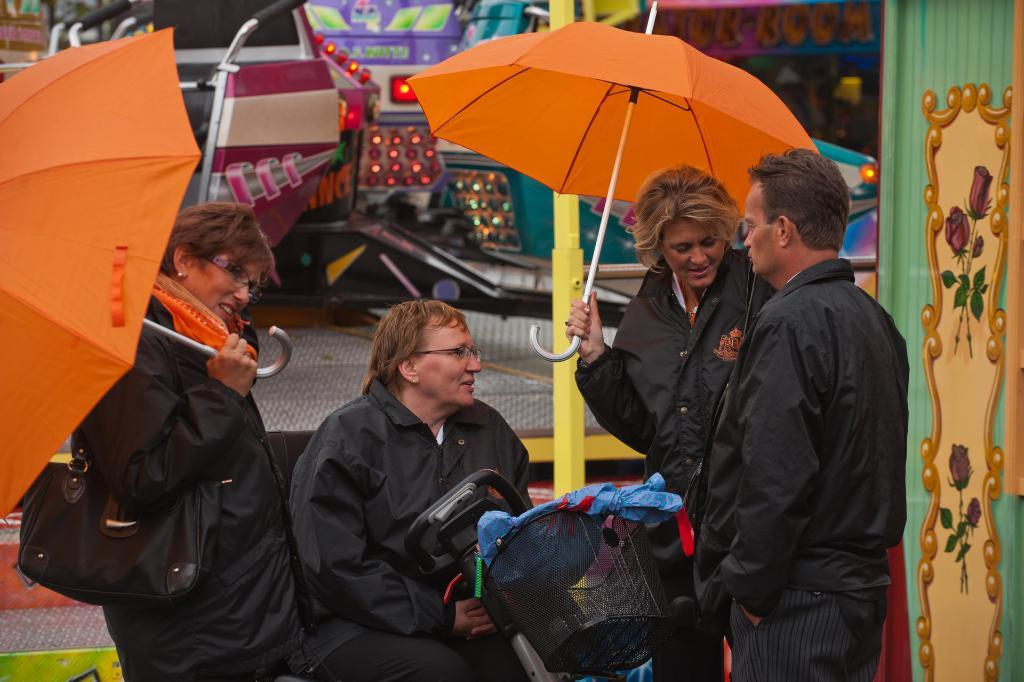How many people are in the group in the image? There is a group of persons in the image, but the exact number cannot be determined from the provided facts. What are some of the persons in the group doing? Some persons in the group are holding umbrellas. What can be seen in the background of the image? There are objects visible in the background of the image, but their specific nature cannot be determined from the provided facts. What type of ticket is required to enter the event in the image? There is no event or ticket present in the image; it features a group of persons and some holding umbrellas. How would you describe the taste of the rain in the image? There is no rain present in the image, so it is not possible to describe its taste. 